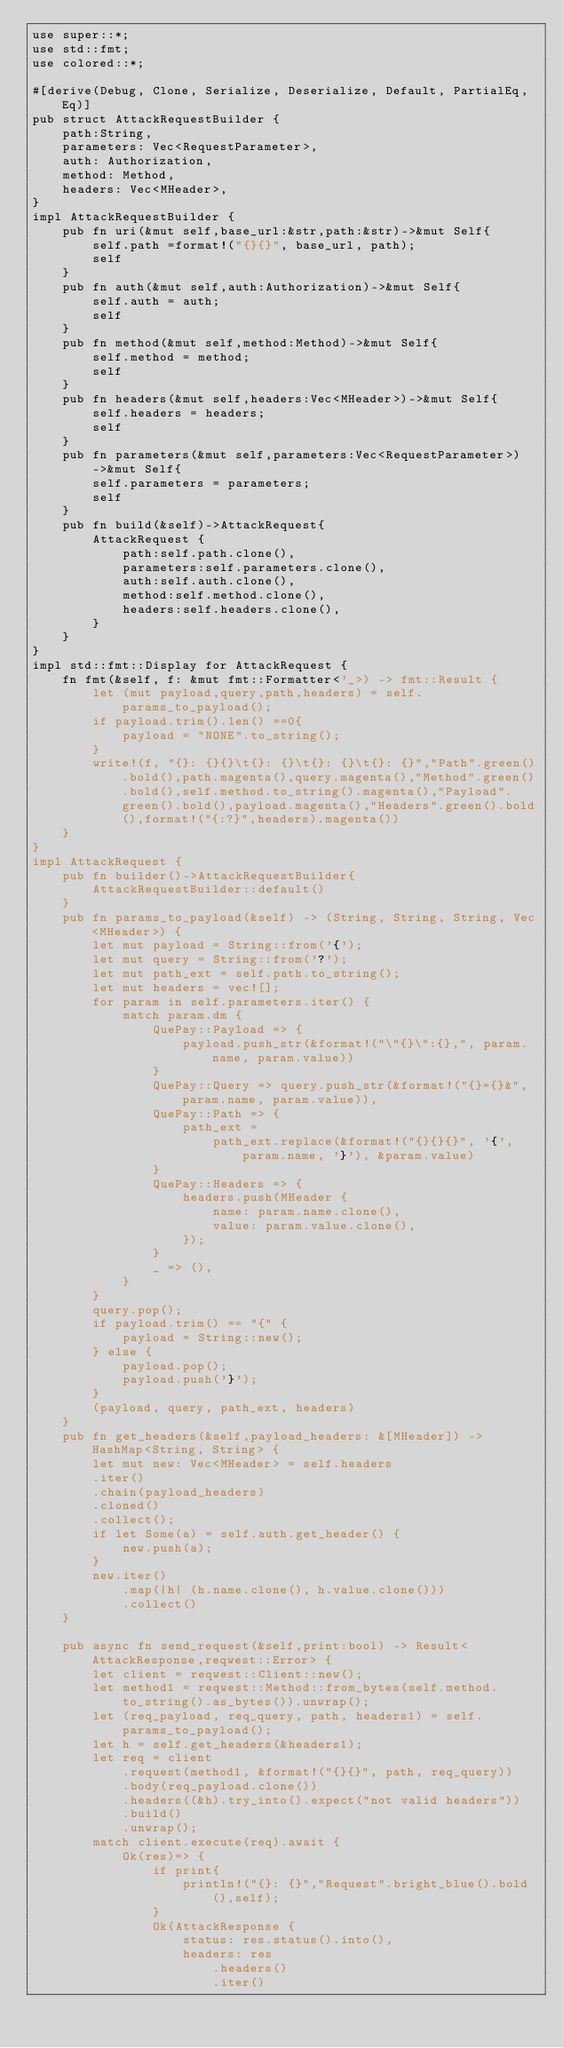Convert code to text. <code><loc_0><loc_0><loc_500><loc_500><_Rust_>use super::*;
use std::fmt;
use colored::*;

#[derive(Debug, Clone, Serialize, Deserialize, Default, PartialEq, Eq)]
pub struct AttackRequestBuilder {
    path:String,
    parameters: Vec<RequestParameter>,
    auth: Authorization,
    method: Method,
    headers: Vec<MHeader>,
}
impl AttackRequestBuilder {
    pub fn uri(&mut self,base_url:&str,path:&str)->&mut Self{
        self.path =format!("{}{}", base_url, path);
        self
    }
    pub fn auth(&mut self,auth:Authorization)->&mut Self{
        self.auth = auth;
        self
    }
    pub fn method(&mut self,method:Method)->&mut Self{
        self.method = method;
        self
    }
    pub fn headers(&mut self,headers:Vec<MHeader>)->&mut Self{
        self.headers = headers;
        self
    }
    pub fn parameters(&mut self,parameters:Vec<RequestParameter>)->&mut Self{
        self.parameters = parameters;
        self
    }
    pub fn build(&self)->AttackRequest{
        AttackRequest {
            path:self.path.clone(),
            parameters:self.parameters.clone(),
            auth:self.auth.clone(),
            method:self.method.clone(),
            headers:self.headers.clone(),
        }
    }
}
impl std::fmt::Display for AttackRequest {
    fn fmt(&self, f: &mut fmt::Formatter<'_>) -> fmt::Result {
        let (mut payload,query,path,headers) = self.params_to_payload();  
        if payload.trim().len() ==0{
            payload = "NONE".to_string();
        }
        write!(f, "{}: {}{}\t{}: {}\t{}: {}\t{}: {}","Path".green().bold(),path.magenta(),query.magenta(),"Method".green().bold(),self.method.to_string().magenta(),"Payload".green().bold(),payload.magenta(),"Headers".green().bold(),format!("{:?}",headers).magenta())
    }
}
impl AttackRequest {
    pub fn builder()->AttackRequestBuilder{
        AttackRequestBuilder::default()
    }
    pub fn params_to_payload(&self) -> (String, String, String, Vec<MHeader>) {
        let mut payload = String::from('{');
        let mut query = String::from('?');
        let mut path_ext = self.path.to_string();
        let mut headers = vec![];
        for param in self.parameters.iter() {
            match param.dm {
                QuePay::Payload => {
                    payload.push_str(&format!("\"{}\":{},", param.name, param.value))
                }
                QuePay::Query => query.push_str(&format!("{}={}&", param.name, param.value)),
                QuePay::Path => {
                    path_ext =
                        path_ext.replace(&format!("{}{}{}", '{', param.name, '}'), &param.value)
                }
                QuePay::Headers => {
                    headers.push(MHeader {
                        name: param.name.clone(),
                        value: param.value.clone(),
                    });
                }
                _ => (),
            }
        }
        query.pop();
        if payload.trim() == "{" {
            payload = String::new();
        } else {
            payload.pop();
            payload.push('}');
        }
        (payload, query, path_ext, headers)
    }
    pub fn get_headers(&self,payload_headers: &[MHeader]) -> HashMap<String, String> {
        let mut new: Vec<MHeader> = self.headers
        .iter()
        .chain(payload_headers)
        .cloned()
        .collect();
        if let Some(a) = self.auth.get_header() {
            new.push(a);
        }
        new.iter()
            .map(|h| (h.name.clone(), h.value.clone()))
            .collect()
    }

    pub async fn send_request(&self,print:bool) -> Result<AttackResponse,reqwest::Error> {
        let client = reqwest::Client::new();
        let method1 = reqwest::Method::from_bytes(self.method.to_string().as_bytes()).unwrap();
        let (req_payload, req_query, path, headers1) = self.params_to_payload();
        let h = self.get_headers(&headers1);
        let req = client
            .request(method1, &format!("{}{}", path, req_query))
            .body(req_payload.clone())
            .headers((&h).try_into().expect("not valid headers"))
            .build()
            .unwrap();
        match client.execute(req).await { 
            Ok(res)=> {
                if print{
                    println!("{}: {}","Request".bright_blue().bold(),self);
                }
                Ok(AttackResponse {
                    status: res.status().into(),
                    headers: res
                        .headers()
                        .iter()</code> 